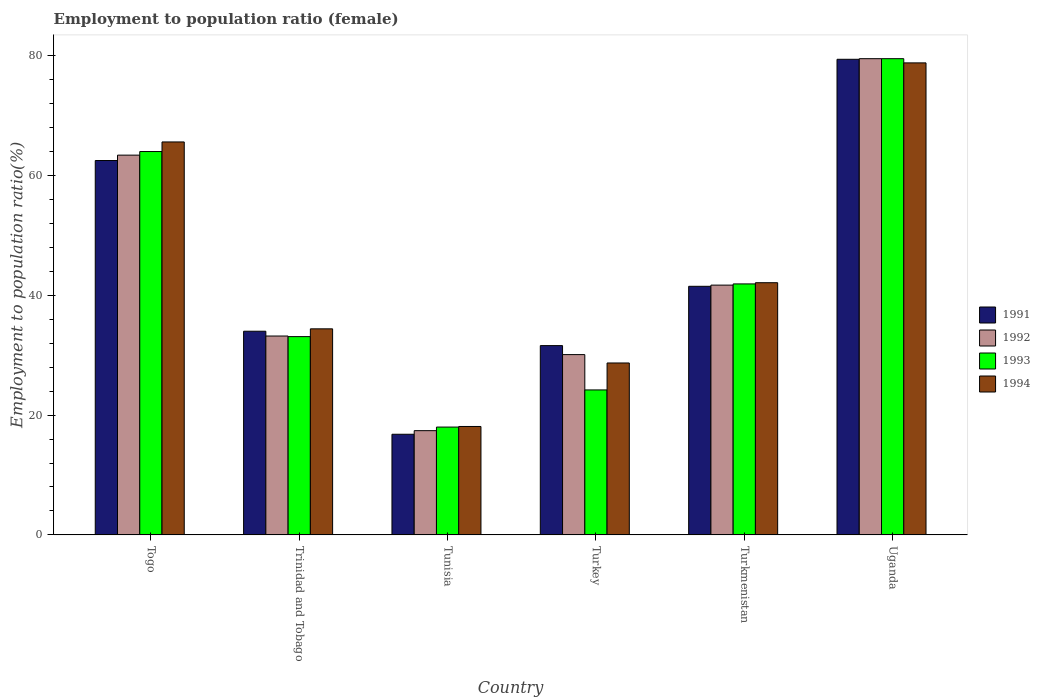How many different coloured bars are there?
Offer a terse response. 4. Are the number of bars per tick equal to the number of legend labels?
Make the answer very short. Yes. How many bars are there on the 4th tick from the right?
Your answer should be very brief. 4. What is the label of the 5th group of bars from the left?
Make the answer very short. Turkmenistan. In how many cases, is the number of bars for a given country not equal to the number of legend labels?
Keep it short and to the point. 0. What is the employment to population ratio in 1994 in Togo?
Provide a short and direct response. 65.6. Across all countries, what is the maximum employment to population ratio in 1993?
Ensure brevity in your answer.  79.5. In which country was the employment to population ratio in 1993 maximum?
Your response must be concise. Uganda. In which country was the employment to population ratio in 1992 minimum?
Keep it short and to the point. Tunisia. What is the total employment to population ratio in 1993 in the graph?
Your response must be concise. 260.7. What is the difference between the employment to population ratio in 1994 in Trinidad and Tobago and that in Turkmenistan?
Your answer should be compact. -7.7. What is the average employment to population ratio in 1994 per country?
Your answer should be compact. 44.62. What is the difference between the employment to population ratio of/in 1991 and employment to population ratio of/in 1993 in Tunisia?
Keep it short and to the point. -1.2. What is the ratio of the employment to population ratio in 1994 in Togo to that in Trinidad and Tobago?
Provide a short and direct response. 1.91. Is the employment to population ratio in 1993 in Tunisia less than that in Uganda?
Keep it short and to the point. Yes. What is the difference between the highest and the second highest employment to population ratio in 1992?
Your answer should be very brief. -21.7. What is the difference between the highest and the lowest employment to population ratio in 1993?
Give a very brief answer. 61.5. In how many countries, is the employment to population ratio in 1992 greater than the average employment to population ratio in 1992 taken over all countries?
Offer a terse response. 2. Is the sum of the employment to population ratio in 1993 in Togo and Uganda greater than the maximum employment to population ratio in 1994 across all countries?
Give a very brief answer. Yes. Is it the case that in every country, the sum of the employment to population ratio in 1994 and employment to population ratio in 1992 is greater than the sum of employment to population ratio in 1991 and employment to population ratio in 1993?
Your response must be concise. No. What does the 3rd bar from the left in Turkmenistan represents?
Give a very brief answer. 1993. What does the 4th bar from the right in Tunisia represents?
Keep it short and to the point. 1991. Is it the case that in every country, the sum of the employment to population ratio in 1993 and employment to population ratio in 1991 is greater than the employment to population ratio in 1994?
Provide a succinct answer. Yes. Are all the bars in the graph horizontal?
Offer a terse response. No. What is the difference between two consecutive major ticks on the Y-axis?
Offer a very short reply. 20. Are the values on the major ticks of Y-axis written in scientific E-notation?
Give a very brief answer. No. Does the graph contain grids?
Ensure brevity in your answer.  No. Where does the legend appear in the graph?
Make the answer very short. Center right. How many legend labels are there?
Offer a terse response. 4. What is the title of the graph?
Make the answer very short. Employment to population ratio (female). Does "1986" appear as one of the legend labels in the graph?
Provide a short and direct response. No. What is the label or title of the X-axis?
Give a very brief answer. Country. What is the label or title of the Y-axis?
Provide a short and direct response. Employment to population ratio(%). What is the Employment to population ratio(%) in 1991 in Togo?
Offer a terse response. 62.5. What is the Employment to population ratio(%) of 1992 in Togo?
Offer a very short reply. 63.4. What is the Employment to population ratio(%) in 1994 in Togo?
Keep it short and to the point. 65.6. What is the Employment to population ratio(%) in 1992 in Trinidad and Tobago?
Your answer should be very brief. 33.2. What is the Employment to population ratio(%) of 1993 in Trinidad and Tobago?
Offer a terse response. 33.1. What is the Employment to population ratio(%) of 1994 in Trinidad and Tobago?
Provide a short and direct response. 34.4. What is the Employment to population ratio(%) of 1991 in Tunisia?
Your answer should be compact. 16.8. What is the Employment to population ratio(%) of 1992 in Tunisia?
Your response must be concise. 17.4. What is the Employment to population ratio(%) of 1994 in Tunisia?
Offer a terse response. 18.1. What is the Employment to population ratio(%) in 1991 in Turkey?
Provide a succinct answer. 31.6. What is the Employment to population ratio(%) in 1992 in Turkey?
Your response must be concise. 30.1. What is the Employment to population ratio(%) in 1993 in Turkey?
Offer a terse response. 24.2. What is the Employment to population ratio(%) of 1994 in Turkey?
Your answer should be compact. 28.7. What is the Employment to population ratio(%) in 1991 in Turkmenistan?
Offer a terse response. 41.5. What is the Employment to population ratio(%) of 1992 in Turkmenistan?
Offer a very short reply. 41.7. What is the Employment to population ratio(%) of 1993 in Turkmenistan?
Keep it short and to the point. 41.9. What is the Employment to population ratio(%) of 1994 in Turkmenistan?
Your response must be concise. 42.1. What is the Employment to population ratio(%) of 1991 in Uganda?
Your answer should be compact. 79.4. What is the Employment to population ratio(%) in 1992 in Uganda?
Offer a very short reply. 79.5. What is the Employment to population ratio(%) in 1993 in Uganda?
Provide a short and direct response. 79.5. What is the Employment to population ratio(%) in 1994 in Uganda?
Keep it short and to the point. 78.8. Across all countries, what is the maximum Employment to population ratio(%) of 1991?
Offer a terse response. 79.4. Across all countries, what is the maximum Employment to population ratio(%) of 1992?
Offer a terse response. 79.5. Across all countries, what is the maximum Employment to population ratio(%) of 1993?
Offer a terse response. 79.5. Across all countries, what is the maximum Employment to population ratio(%) in 1994?
Your response must be concise. 78.8. Across all countries, what is the minimum Employment to population ratio(%) in 1991?
Give a very brief answer. 16.8. Across all countries, what is the minimum Employment to population ratio(%) of 1992?
Your answer should be very brief. 17.4. Across all countries, what is the minimum Employment to population ratio(%) in 1993?
Your answer should be very brief. 18. Across all countries, what is the minimum Employment to population ratio(%) in 1994?
Offer a terse response. 18.1. What is the total Employment to population ratio(%) in 1991 in the graph?
Keep it short and to the point. 265.8. What is the total Employment to population ratio(%) of 1992 in the graph?
Ensure brevity in your answer.  265.3. What is the total Employment to population ratio(%) in 1993 in the graph?
Keep it short and to the point. 260.7. What is the total Employment to population ratio(%) of 1994 in the graph?
Offer a terse response. 267.7. What is the difference between the Employment to population ratio(%) in 1992 in Togo and that in Trinidad and Tobago?
Give a very brief answer. 30.2. What is the difference between the Employment to population ratio(%) of 1993 in Togo and that in Trinidad and Tobago?
Your response must be concise. 30.9. What is the difference between the Employment to population ratio(%) of 1994 in Togo and that in Trinidad and Tobago?
Ensure brevity in your answer.  31.2. What is the difference between the Employment to population ratio(%) in 1991 in Togo and that in Tunisia?
Your response must be concise. 45.7. What is the difference between the Employment to population ratio(%) in 1994 in Togo and that in Tunisia?
Provide a short and direct response. 47.5. What is the difference between the Employment to population ratio(%) of 1991 in Togo and that in Turkey?
Offer a very short reply. 30.9. What is the difference between the Employment to population ratio(%) of 1992 in Togo and that in Turkey?
Your response must be concise. 33.3. What is the difference between the Employment to population ratio(%) of 1993 in Togo and that in Turkey?
Provide a succinct answer. 39.8. What is the difference between the Employment to population ratio(%) of 1994 in Togo and that in Turkey?
Provide a succinct answer. 36.9. What is the difference between the Employment to population ratio(%) of 1991 in Togo and that in Turkmenistan?
Make the answer very short. 21. What is the difference between the Employment to population ratio(%) in 1992 in Togo and that in Turkmenistan?
Offer a terse response. 21.7. What is the difference between the Employment to population ratio(%) in 1993 in Togo and that in Turkmenistan?
Offer a very short reply. 22.1. What is the difference between the Employment to population ratio(%) in 1991 in Togo and that in Uganda?
Offer a very short reply. -16.9. What is the difference between the Employment to population ratio(%) in 1992 in Togo and that in Uganda?
Give a very brief answer. -16.1. What is the difference between the Employment to population ratio(%) of 1993 in Togo and that in Uganda?
Offer a very short reply. -15.5. What is the difference between the Employment to population ratio(%) in 1994 in Togo and that in Uganda?
Your response must be concise. -13.2. What is the difference between the Employment to population ratio(%) in 1991 in Trinidad and Tobago and that in Tunisia?
Keep it short and to the point. 17.2. What is the difference between the Employment to population ratio(%) of 1992 in Trinidad and Tobago and that in Tunisia?
Provide a short and direct response. 15.8. What is the difference between the Employment to population ratio(%) in 1993 in Trinidad and Tobago and that in Tunisia?
Offer a terse response. 15.1. What is the difference between the Employment to population ratio(%) in 1994 in Trinidad and Tobago and that in Tunisia?
Offer a terse response. 16.3. What is the difference between the Employment to population ratio(%) of 1993 in Trinidad and Tobago and that in Turkey?
Your response must be concise. 8.9. What is the difference between the Employment to population ratio(%) in 1994 in Trinidad and Tobago and that in Turkey?
Your answer should be compact. 5.7. What is the difference between the Employment to population ratio(%) of 1994 in Trinidad and Tobago and that in Turkmenistan?
Provide a short and direct response. -7.7. What is the difference between the Employment to population ratio(%) in 1991 in Trinidad and Tobago and that in Uganda?
Give a very brief answer. -45.4. What is the difference between the Employment to population ratio(%) in 1992 in Trinidad and Tobago and that in Uganda?
Offer a very short reply. -46.3. What is the difference between the Employment to population ratio(%) of 1993 in Trinidad and Tobago and that in Uganda?
Offer a terse response. -46.4. What is the difference between the Employment to population ratio(%) in 1994 in Trinidad and Tobago and that in Uganda?
Your answer should be compact. -44.4. What is the difference between the Employment to population ratio(%) in 1991 in Tunisia and that in Turkey?
Keep it short and to the point. -14.8. What is the difference between the Employment to population ratio(%) in 1992 in Tunisia and that in Turkey?
Make the answer very short. -12.7. What is the difference between the Employment to population ratio(%) of 1993 in Tunisia and that in Turkey?
Give a very brief answer. -6.2. What is the difference between the Employment to population ratio(%) in 1994 in Tunisia and that in Turkey?
Ensure brevity in your answer.  -10.6. What is the difference between the Employment to population ratio(%) of 1991 in Tunisia and that in Turkmenistan?
Provide a short and direct response. -24.7. What is the difference between the Employment to population ratio(%) of 1992 in Tunisia and that in Turkmenistan?
Your answer should be compact. -24.3. What is the difference between the Employment to population ratio(%) of 1993 in Tunisia and that in Turkmenistan?
Your answer should be very brief. -23.9. What is the difference between the Employment to population ratio(%) of 1994 in Tunisia and that in Turkmenistan?
Your response must be concise. -24. What is the difference between the Employment to population ratio(%) in 1991 in Tunisia and that in Uganda?
Your response must be concise. -62.6. What is the difference between the Employment to population ratio(%) in 1992 in Tunisia and that in Uganda?
Keep it short and to the point. -62.1. What is the difference between the Employment to population ratio(%) of 1993 in Tunisia and that in Uganda?
Ensure brevity in your answer.  -61.5. What is the difference between the Employment to population ratio(%) of 1994 in Tunisia and that in Uganda?
Make the answer very short. -60.7. What is the difference between the Employment to population ratio(%) in 1991 in Turkey and that in Turkmenistan?
Ensure brevity in your answer.  -9.9. What is the difference between the Employment to population ratio(%) in 1993 in Turkey and that in Turkmenistan?
Provide a short and direct response. -17.7. What is the difference between the Employment to population ratio(%) in 1994 in Turkey and that in Turkmenistan?
Offer a very short reply. -13.4. What is the difference between the Employment to population ratio(%) of 1991 in Turkey and that in Uganda?
Make the answer very short. -47.8. What is the difference between the Employment to population ratio(%) of 1992 in Turkey and that in Uganda?
Your response must be concise. -49.4. What is the difference between the Employment to population ratio(%) of 1993 in Turkey and that in Uganda?
Your answer should be compact. -55.3. What is the difference between the Employment to population ratio(%) of 1994 in Turkey and that in Uganda?
Give a very brief answer. -50.1. What is the difference between the Employment to population ratio(%) in 1991 in Turkmenistan and that in Uganda?
Give a very brief answer. -37.9. What is the difference between the Employment to population ratio(%) of 1992 in Turkmenistan and that in Uganda?
Your answer should be compact. -37.8. What is the difference between the Employment to population ratio(%) of 1993 in Turkmenistan and that in Uganda?
Give a very brief answer. -37.6. What is the difference between the Employment to population ratio(%) in 1994 in Turkmenistan and that in Uganda?
Provide a succinct answer. -36.7. What is the difference between the Employment to population ratio(%) in 1991 in Togo and the Employment to population ratio(%) in 1992 in Trinidad and Tobago?
Offer a very short reply. 29.3. What is the difference between the Employment to population ratio(%) of 1991 in Togo and the Employment to population ratio(%) of 1993 in Trinidad and Tobago?
Provide a short and direct response. 29.4. What is the difference between the Employment to population ratio(%) of 1991 in Togo and the Employment to population ratio(%) of 1994 in Trinidad and Tobago?
Offer a very short reply. 28.1. What is the difference between the Employment to population ratio(%) in 1992 in Togo and the Employment to population ratio(%) in 1993 in Trinidad and Tobago?
Ensure brevity in your answer.  30.3. What is the difference between the Employment to population ratio(%) of 1993 in Togo and the Employment to population ratio(%) of 1994 in Trinidad and Tobago?
Make the answer very short. 29.6. What is the difference between the Employment to population ratio(%) of 1991 in Togo and the Employment to population ratio(%) of 1992 in Tunisia?
Your answer should be compact. 45.1. What is the difference between the Employment to population ratio(%) in 1991 in Togo and the Employment to population ratio(%) in 1993 in Tunisia?
Provide a short and direct response. 44.5. What is the difference between the Employment to population ratio(%) of 1991 in Togo and the Employment to population ratio(%) of 1994 in Tunisia?
Provide a short and direct response. 44.4. What is the difference between the Employment to population ratio(%) of 1992 in Togo and the Employment to population ratio(%) of 1993 in Tunisia?
Offer a terse response. 45.4. What is the difference between the Employment to population ratio(%) in 1992 in Togo and the Employment to population ratio(%) in 1994 in Tunisia?
Your answer should be very brief. 45.3. What is the difference between the Employment to population ratio(%) in 1993 in Togo and the Employment to population ratio(%) in 1994 in Tunisia?
Offer a very short reply. 45.9. What is the difference between the Employment to population ratio(%) of 1991 in Togo and the Employment to population ratio(%) of 1992 in Turkey?
Your answer should be very brief. 32.4. What is the difference between the Employment to population ratio(%) of 1991 in Togo and the Employment to population ratio(%) of 1993 in Turkey?
Offer a very short reply. 38.3. What is the difference between the Employment to population ratio(%) in 1991 in Togo and the Employment to population ratio(%) in 1994 in Turkey?
Your response must be concise. 33.8. What is the difference between the Employment to population ratio(%) in 1992 in Togo and the Employment to population ratio(%) in 1993 in Turkey?
Your response must be concise. 39.2. What is the difference between the Employment to population ratio(%) in 1992 in Togo and the Employment to population ratio(%) in 1994 in Turkey?
Keep it short and to the point. 34.7. What is the difference between the Employment to population ratio(%) in 1993 in Togo and the Employment to population ratio(%) in 1994 in Turkey?
Offer a terse response. 35.3. What is the difference between the Employment to population ratio(%) of 1991 in Togo and the Employment to population ratio(%) of 1992 in Turkmenistan?
Keep it short and to the point. 20.8. What is the difference between the Employment to population ratio(%) in 1991 in Togo and the Employment to population ratio(%) in 1993 in Turkmenistan?
Your response must be concise. 20.6. What is the difference between the Employment to population ratio(%) of 1991 in Togo and the Employment to population ratio(%) of 1994 in Turkmenistan?
Your answer should be compact. 20.4. What is the difference between the Employment to population ratio(%) in 1992 in Togo and the Employment to population ratio(%) in 1993 in Turkmenistan?
Your answer should be very brief. 21.5. What is the difference between the Employment to population ratio(%) in 1992 in Togo and the Employment to population ratio(%) in 1994 in Turkmenistan?
Offer a very short reply. 21.3. What is the difference between the Employment to population ratio(%) of 1993 in Togo and the Employment to population ratio(%) of 1994 in Turkmenistan?
Provide a succinct answer. 21.9. What is the difference between the Employment to population ratio(%) of 1991 in Togo and the Employment to population ratio(%) of 1993 in Uganda?
Offer a very short reply. -17. What is the difference between the Employment to population ratio(%) of 1991 in Togo and the Employment to population ratio(%) of 1994 in Uganda?
Provide a short and direct response. -16.3. What is the difference between the Employment to population ratio(%) of 1992 in Togo and the Employment to population ratio(%) of 1993 in Uganda?
Keep it short and to the point. -16.1. What is the difference between the Employment to population ratio(%) of 1992 in Togo and the Employment to population ratio(%) of 1994 in Uganda?
Make the answer very short. -15.4. What is the difference between the Employment to population ratio(%) of 1993 in Togo and the Employment to population ratio(%) of 1994 in Uganda?
Provide a succinct answer. -14.8. What is the difference between the Employment to population ratio(%) in 1991 in Trinidad and Tobago and the Employment to population ratio(%) in 1992 in Tunisia?
Offer a very short reply. 16.6. What is the difference between the Employment to population ratio(%) of 1993 in Trinidad and Tobago and the Employment to population ratio(%) of 1994 in Tunisia?
Your response must be concise. 15. What is the difference between the Employment to population ratio(%) in 1991 in Trinidad and Tobago and the Employment to population ratio(%) in 1992 in Turkey?
Offer a very short reply. 3.9. What is the difference between the Employment to population ratio(%) in 1991 in Trinidad and Tobago and the Employment to population ratio(%) in 1994 in Turkey?
Keep it short and to the point. 5.3. What is the difference between the Employment to population ratio(%) of 1993 in Trinidad and Tobago and the Employment to population ratio(%) of 1994 in Turkey?
Keep it short and to the point. 4.4. What is the difference between the Employment to population ratio(%) of 1991 in Trinidad and Tobago and the Employment to population ratio(%) of 1994 in Turkmenistan?
Provide a short and direct response. -8.1. What is the difference between the Employment to population ratio(%) in 1991 in Trinidad and Tobago and the Employment to population ratio(%) in 1992 in Uganda?
Provide a short and direct response. -45.5. What is the difference between the Employment to population ratio(%) in 1991 in Trinidad and Tobago and the Employment to population ratio(%) in 1993 in Uganda?
Make the answer very short. -45.5. What is the difference between the Employment to population ratio(%) in 1991 in Trinidad and Tobago and the Employment to population ratio(%) in 1994 in Uganda?
Offer a terse response. -44.8. What is the difference between the Employment to population ratio(%) of 1992 in Trinidad and Tobago and the Employment to population ratio(%) of 1993 in Uganda?
Provide a succinct answer. -46.3. What is the difference between the Employment to population ratio(%) of 1992 in Trinidad and Tobago and the Employment to population ratio(%) of 1994 in Uganda?
Offer a terse response. -45.6. What is the difference between the Employment to population ratio(%) in 1993 in Trinidad and Tobago and the Employment to population ratio(%) in 1994 in Uganda?
Your answer should be compact. -45.7. What is the difference between the Employment to population ratio(%) in 1991 in Tunisia and the Employment to population ratio(%) in 1992 in Turkey?
Your answer should be compact. -13.3. What is the difference between the Employment to population ratio(%) of 1992 in Tunisia and the Employment to population ratio(%) of 1994 in Turkey?
Your response must be concise. -11.3. What is the difference between the Employment to population ratio(%) in 1991 in Tunisia and the Employment to population ratio(%) in 1992 in Turkmenistan?
Offer a terse response. -24.9. What is the difference between the Employment to population ratio(%) in 1991 in Tunisia and the Employment to population ratio(%) in 1993 in Turkmenistan?
Offer a very short reply. -25.1. What is the difference between the Employment to population ratio(%) in 1991 in Tunisia and the Employment to population ratio(%) in 1994 in Turkmenistan?
Your answer should be compact. -25.3. What is the difference between the Employment to population ratio(%) in 1992 in Tunisia and the Employment to population ratio(%) in 1993 in Turkmenistan?
Provide a short and direct response. -24.5. What is the difference between the Employment to population ratio(%) in 1992 in Tunisia and the Employment to population ratio(%) in 1994 in Turkmenistan?
Keep it short and to the point. -24.7. What is the difference between the Employment to population ratio(%) in 1993 in Tunisia and the Employment to population ratio(%) in 1994 in Turkmenistan?
Your answer should be very brief. -24.1. What is the difference between the Employment to population ratio(%) in 1991 in Tunisia and the Employment to population ratio(%) in 1992 in Uganda?
Make the answer very short. -62.7. What is the difference between the Employment to population ratio(%) of 1991 in Tunisia and the Employment to population ratio(%) of 1993 in Uganda?
Make the answer very short. -62.7. What is the difference between the Employment to population ratio(%) in 1991 in Tunisia and the Employment to population ratio(%) in 1994 in Uganda?
Give a very brief answer. -62. What is the difference between the Employment to population ratio(%) of 1992 in Tunisia and the Employment to population ratio(%) of 1993 in Uganda?
Your answer should be compact. -62.1. What is the difference between the Employment to population ratio(%) in 1992 in Tunisia and the Employment to population ratio(%) in 1994 in Uganda?
Offer a terse response. -61.4. What is the difference between the Employment to population ratio(%) in 1993 in Tunisia and the Employment to population ratio(%) in 1994 in Uganda?
Offer a terse response. -60.8. What is the difference between the Employment to population ratio(%) of 1991 in Turkey and the Employment to population ratio(%) of 1992 in Turkmenistan?
Make the answer very short. -10.1. What is the difference between the Employment to population ratio(%) in 1991 in Turkey and the Employment to population ratio(%) in 1993 in Turkmenistan?
Provide a short and direct response. -10.3. What is the difference between the Employment to population ratio(%) of 1993 in Turkey and the Employment to population ratio(%) of 1994 in Turkmenistan?
Offer a very short reply. -17.9. What is the difference between the Employment to population ratio(%) of 1991 in Turkey and the Employment to population ratio(%) of 1992 in Uganda?
Provide a short and direct response. -47.9. What is the difference between the Employment to population ratio(%) of 1991 in Turkey and the Employment to population ratio(%) of 1993 in Uganda?
Ensure brevity in your answer.  -47.9. What is the difference between the Employment to population ratio(%) in 1991 in Turkey and the Employment to population ratio(%) in 1994 in Uganda?
Keep it short and to the point. -47.2. What is the difference between the Employment to population ratio(%) of 1992 in Turkey and the Employment to population ratio(%) of 1993 in Uganda?
Ensure brevity in your answer.  -49.4. What is the difference between the Employment to population ratio(%) in 1992 in Turkey and the Employment to population ratio(%) in 1994 in Uganda?
Ensure brevity in your answer.  -48.7. What is the difference between the Employment to population ratio(%) of 1993 in Turkey and the Employment to population ratio(%) of 1994 in Uganda?
Your response must be concise. -54.6. What is the difference between the Employment to population ratio(%) of 1991 in Turkmenistan and the Employment to population ratio(%) of 1992 in Uganda?
Offer a very short reply. -38. What is the difference between the Employment to population ratio(%) of 1991 in Turkmenistan and the Employment to population ratio(%) of 1993 in Uganda?
Provide a succinct answer. -38. What is the difference between the Employment to population ratio(%) of 1991 in Turkmenistan and the Employment to population ratio(%) of 1994 in Uganda?
Your answer should be compact. -37.3. What is the difference between the Employment to population ratio(%) in 1992 in Turkmenistan and the Employment to population ratio(%) in 1993 in Uganda?
Offer a terse response. -37.8. What is the difference between the Employment to population ratio(%) of 1992 in Turkmenistan and the Employment to population ratio(%) of 1994 in Uganda?
Provide a short and direct response. -37.1. What is the difference between the Employment to population ratio(%) in 1993 in Turkmenistan and the Employment to population ratio(%) in 1994 in Uganda?
Keep it short and to the point. -36.9. What is the average Employment to population ratio(%) of 1991 per country?
Provide a short and direct response. 44.3. What is the average Employment to population ratio(%) of 1992 per country?
Offer a very short reply. 44.22. What is the average Employment to population ratio(%) in 1993 per country?
Make the answer very short. 43.45. What is the average Employment to population ratio(%) in 1994 per country?
Make the answer very short. 44.62. What is the difference between the Employment to population ratio(%) of 1991 and Employment to population ratio(%) of 1992 in Togo?
Provide a short and direct response. -0.9. What is the difference between the Employment to population ratio(%) of 1991 and Employment to population ratio(%) of 1993 in Togo?
Ensure brevity in your answer.  -1.5. What is the difference between the Employment to population ratio(%) in 1992 and Employment to population ratio(%) in 1993 in Togo?
Offer a terse response. -0.6. What is the difference between the Employment to population ratio(%) in 1992 and Employment to population ratio(%) in 1994 in Togo?
Your answer should be compact. -2.2. What is the difference between the Employment to population ratio(%) in 1993 and Employment to population ratio(%) in 1994 in Togo?
Ensure brevity in your answer.  -1.6. What is the difference between the Employment to population ratio(%) of 1991 and Employment to population ratio(%) of 1992 in Trinidad and Tobago?
Offer a very short reply. 0.8. What is the difference between the Employment to population ratio(%) in 1991 and Employment to population ratio(%) in 1993 in Trinidad and Tobago?
Your answer should be very brief. 0.9. What is the difference between the Employment to population ratio(%) in 1992 and Employment to population ratio(%) in 1993 in Trinidad and Tobago?
Provide a succinct answer. 0.1. What is the difference between the Employment to population ratio(%) of 1992 and Employment to population ratio(%) of 1994 in Trinidad and Tobago?
Ensure brevity in your answer.  -1.2. What is the difference between the Employment to population ratio(%) in 1993 and Employment to population ratio(%) in 1994 in Trinidad and Tobago?
Ensure brevity in your answer.  -1.3. What is the difference between the Employment to population ratio(%) in 1991 and Employment to population ratio(%) in 1993 in Tunisia?
Your answer should be compact. -1.2. What is the difference between the Employment to population ratio(%) of 1991 and Employment to population ratio(%) of 1994 in Tunisia?
Provide a succinct answer. -1.3. What is the difference between the Employment to population ratio(%) in 1991 and Employment to population ratio(%) in 1992 in Turkey?
Provide a succinct answer. 1.5. What is the difference between the Employment to population ratio(%) of 1991 and Employment to population ratio(%) of 1994 in Turkey?
Ensure brevity in your answer.  2.9. What is the difference between the Employment to population ratio(%) of 1992 and Employment to population ratio(%) of 1993 in Turkey?
Keep it short and to the point. 5.9. What is the difference between the Employment to population ratio(%) in 1993 and Employment to population ratio(%) in 1994 in Turkey?
Your answer should be compact. -4.5. What is the difference between the Employment to population ratio(%) in 1991 and Employment to population ratio(%) in 1993 in Turkmenistan?
Your answer should be compact. -0.4. What is the difference between the Employment to population ratio(%) in 1992 and Employment to population ratio(%) in 1993 in Turkmenistan?
Provide a succinct answer. -0.2. What is the difference between the Employment to population ratio(%) in 1991 and Employment to population ratio(%) in 1993 in Uganda?
Provide a succinct answer. -0.1. What is the difference between the Employment to population ratio(%) of 1991 and Employment to population ratio(%) of 1994 in Uganda?
Make the answer very short. 0.6. What is the difference between the Employment to population ratio(%) of 1992 and Employment to population ratio(%) of 1994 in Uganda?
Provide a short and direct response. 0.7. What is the ratio of the Employment to population ratio(%) of 1991 in Togo to that in Trinidad and Tobago?
Provide a short and direct response. 1.84. What is the ratio of the Employment to population ratio(%) in 1992 in Togo to that in Trinidad and Tobago?
Provide a succinct answer. 1.91. What is the ratio of the Employment to population ratio(%) in 1993 in Togo to that in Trinidad and Tobago?
Your answer should be very brief. 1.93. What is the ratio of the Employment to population ratio(%) of 1994 in Togo to that in Trinidad and Tobago?
Keep it short and to the point. 1.91. What is the ratio of the Employment to population ratio(%) in 1991 in Togo to that in Tunisia?
Offer a terse response. 3.72. What is the ratio of the Employment to population ratio(%) in 1992 in Togo to that in Tunisia?
Your answer should be very brief. 3.64. What is the ratio of the Employment to population ratio(%) of 1993 in Togo to that in Tunisia?
Offer a terse response. 3.56. What is the ratio of the Employment to population ratio(%) of 1994 in Togo to that in Tunisia?
Your answer should be very brief. 3.62. What is the ratio of the Employment to population ratio(%) of 1991 in Togo to that in Turkey?
Provide a succinct answer. 1.98. What is the ratio of the Employment to population ratio(%) of 1992 in Togo to that in Turkey?
Provide a short and direct response. 2.11. What is the ratio of the Employment to population ratio(%) in 1993 in Togo to that in Turkey?
Provide a short and direct response. 2.64. What is the ratio of the Employment to population ratio(%) in 1994 in Togo to that in Turkey?
Make the answer very short. 2.29. What is the ratio of the Employment to population ratio(%) of 1991 in Togo to that in Turkmenistan?
Offer a very short reply. 1.51. What is the ratio of the Employment to population ratio(%) in 1992 in Togo to that in Turkmenistan?
Give a very brief answer. 1.52. What is the ratio of the Employment to population ratio(%) of 1993 in Togo to that in Turkmenistan?
Your response must be concise. 1.53. What is the ratio of the Employment to population ratio(%) in 1994 in Togo to that in Turkmenistan?
Give a very brief answer. 1.56. What is the ratio of the Employment to population ratio(%) in 1991 in Togo to that in Uganda?
Provide a short and direct response. 0.79. What is the ratio of the Employment to population ratio(%) of 1992 in Togo to that in Uganda?
Your answer should be very brief. 0.8. What is the ratio of the Employment to population ratio(%) in 1993 in Togo to that in Uganda?
Your answer should be very brief. 0.81. What is the ratio of the Employment to population ratio(%) in 1994 in Togo to that in Uganda?
Your answer should be compact. 0.83. What is the ratio of the Employment to population ratio(%) of 1991 in Trinidad and Tobago to that in Tunisia?
Ensure brevity in your answer.  2.02. What is the ratio of the Employment to population ratio(%) of 1992 in Trinidad and Tobago to that in Tunisia?
Your response must be concise. 1.91. What is the ratio of the Employment to population ratio(%) of 1993 in Trinidad and Tobago to that in Tunisia?
Your answer should be very brief. 1.84. What is the ratio of the Employment to population ratio(%) of 1994 in Trinidad and Tobago to that in Tunisia?
Make the answer very short. 1.9. What is the ratio of the Employment to population ratio(%) of 1991 in Trinidad and Tobago to that in Turkey?
Ensure brevity in your answer.  1.08. What is the ratio of the Employment to population ratio(%) in 1992 in Trinidad and Tobago to that in Turkey?
Keep it short and to the point. 1.1. What is the ratio of the Employment to population ratio(%) of 1993 in Trinidad and Tobago to that in Turkey?
Give a very brief answer. 1.37. What is the ratio of the Employment to population ratio(%) in 1994 in Trinidad and Tobago to that in Turkey?
Provide a succinct answer. 1.2. What is the ratio of the Employment to population ratio(%) of 1991 in Trinidad and Tobago to that in Turkmenistan?
Your answer should be compact. 0.82. What is the ratio of the Employment to population ratio(%) in 1992 in Trinidad and Tobago to that in Turkmenistan?
Ensure brevity in your answer.  0.8. What is the ratio of the Employment to population ratio(%) of 1993 in Trinidad and Tobago to that in Turkmenistan?
Make the answer very short. 0.79. What is the ratio of the Employment to population ratio(%) in 1994 in Trinidad and Tobago to that in Turkmenistan?
Make the answer very short. 0.82. What is the ratio of the Employment to population ratio(%) of 1991 in Trinidad and Tobago to that in Uganda?
Offer a very short reply. 0.43. What is the ratio of the Employment to population ratio(%) in 1992 in Trinidad and Tobago to that in Uganda?
Your answer should be compact. 0.42. What is the ratio of the Employment to population ratio(%) in 1993 in Trinidad and Tobago to that in Uganda?
Ensure brevity in your answer.  0.42. What is the ratio of the Employment to population ratio(%) of 1994 in Trinidad and Tobago to that in Uganda?
Keep it short and to the point. 0.44. What is the ratio of the Employment to population ratio(%) of 1991 in Tunisia to that in Turkey?
Provide a succinct answer. 0.53. What is the ratio of the Employment to population ratio(%) of 1992 in Tunisia to that in Turkey?
Provide a succinct answer. 0.58. What is the ratio of the Employment to population ratio(%) of 1993 in Tunisia to that in Turkey?
Provide a succinct answer. 0.74. What is the ratio of the Employment to population ratio(%) of 1994 in Tunisia to that in Turkey?
Your response must be concise. 0.63. What is the ratio of the Employment to population ratio(%) of 1991 in Tunisia to that in Turkmenistan?
Your response must be concise. 0.4. What is the ratio of the Employment to population ratio(%) of 1992 in Tunisia to that in Turkmenistan?
Your response must be concise. 0.42. What is the ratio of the Employment to population ratio(%) of 1993 in Tunisia to that in Turkmenistan?
Provide a succinct answer. 0.43. What is the ratio of the Employment to population ratio(%) in 1994 in Tunisia to that in Turkmenistan?
Your response must be concise. 0.43. What is the ratio of the Employment to population ratio(%) of 1991 in Tunisia to that in Uganda?
Make the answer very short. 0.21. What is the ratio of the Employment to population ratio(%) in 1992 in Tunisia to that in Uganda?
Provide a short and direct response. 0.22. What is the ratio of the Employment to population ratio(%) in 1993 in Tunisia to that in Uganda?
Your answer should be very brief. 0.23. What is the ratio of the Employment to population ratio(%) in 1994 in Tunisia to that in Uganda?
Your answer should be compact. 0.23. What is the ratio of the Employment to population ratio(%) in 1991 in Turkey to that in Turkmenistan?
Your answer should be compact. 0.76. What is the ratio of the Employment to population ratio(%) in 1992 in Turkey to that in Turkmenistan?
Provide a short and direct response. 0.72. What is the ratio of the Employment to population ratio(%) in 1993 in Turkey to that in Turkmenistan?
Give a very brief answer. 0.58. What is the ratio of the Employment to population ratio(%) in 1994 in Turkey to that in Turkmenistan?
Ensure brevity in your answer.  0.68. What is the ratio of the Employment to population ratio(%) of 1991 in Turkey to that in Uganda?
Make the answer very short. 0.4. What is the ratio of the Employment to population ratio(%) of 1992 in Turkey to that in Uganda?
Make the answer very short. 0.38. What is the ratio of the Employment to population ratio(%) of 1993 in Turkey to that in Uganda?
Your answer should be very brief. 0.3. What is the ratio of the Employment to population ratio(%) in 1994 in Turkey to that in Uganda?
Provide a succinct answer. 0.36. What is the ratio of the Employment to population ratio(%) of 1991 in Turkmenistan to that in Uganda?
Provide a short and direct response. 0.52. What is the ratio of the Employment to population ratio(%) of 1992 in Turkmenistan to that in Uganda?
Ensure brevity in your answer.  0.52. What is the ratio of the Employment to population ratio(%) of 1993 in Turkmenistan to that in Uganda?
Give a very brief answer. 0.53. What is the ratio of the Employment to population ratio(%) of 1994 in Turkmenistan to that in Uganda?
Your answer should be compact. 0.53. What is the difference between the highest and the second highest Employment to population ratio(%) in 1992?
Make the answer very short. 16.1. What is the difference between the highest and the second highest Employment to population ratio(%) of 1994?
Offer a terse response. 13.2. What is the difference between the highest and the lowest Employment to population ratio(%) of 1991?
Make the answer very short. 62.6. What is the difference between the highest and the lowest Employment to population ratio(%) of 1992?
Your answer should be very brief. 62.1. What is the difference between the highest and the lowest Employment to population ratio(%) in 1993?
Provide a succinct answer. 61.5. What is the difference between the highest and the lowest Employment to population ratio(%) of 1994?
Ensure brevity in your answer.  60.7. 